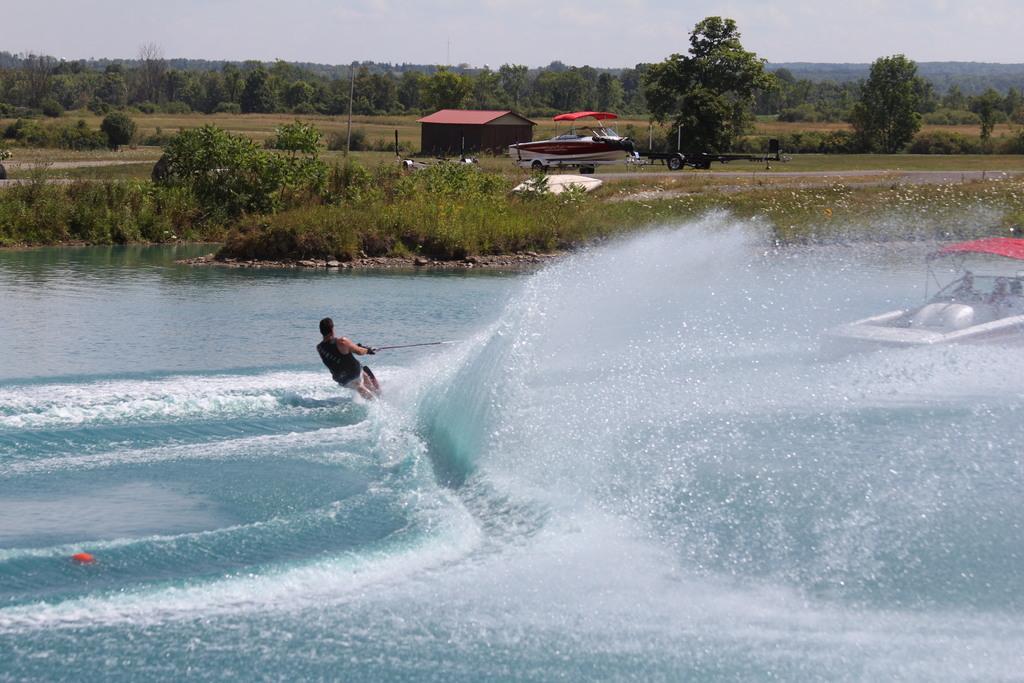Could you give a brief overview of what you see in this image? In this picture there is a man who is doing surfing. On the right I can see the boat on the water. In the background I can see the trees, plants, grass, shed and vehicle. At the top I can see the sky and clouds. 